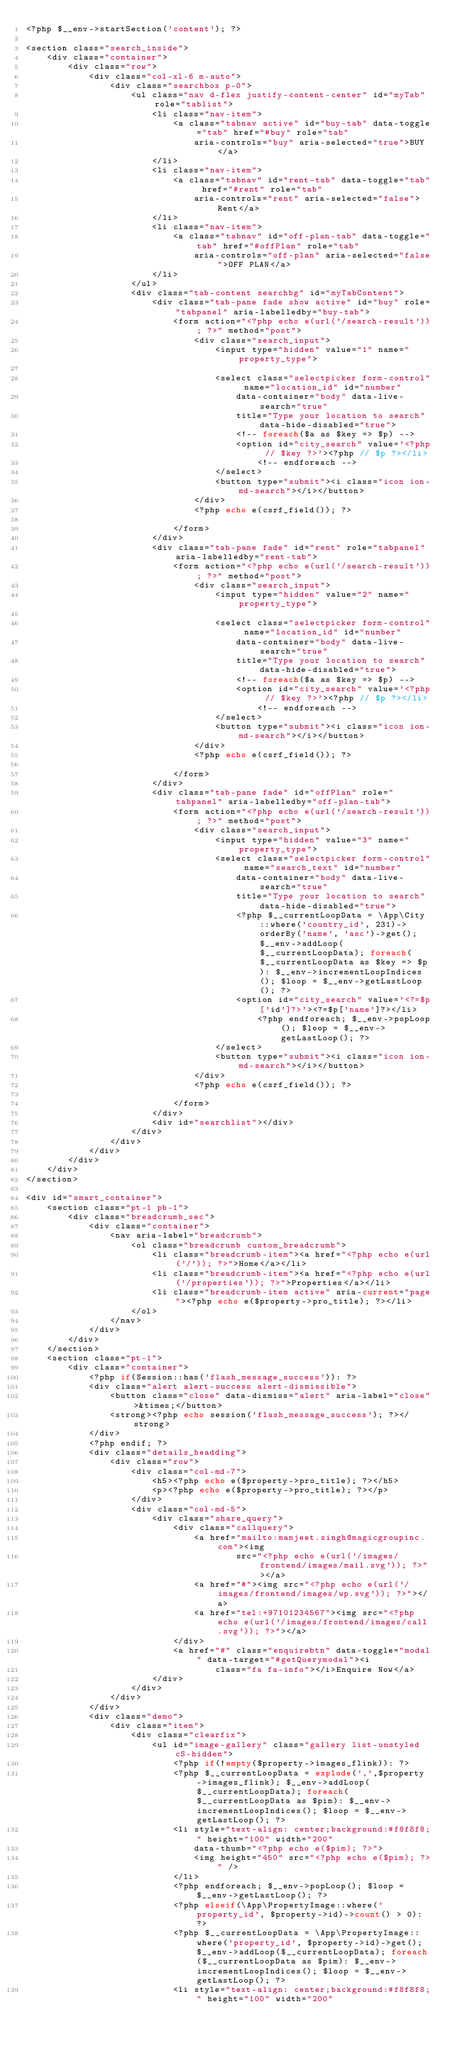<code> <loc_0><loc_0><loc_500><loc_500><_PHP_><?php $__env->startSection('content'); ?>

<section class="search_inside">
    <div class="container">
        <div class="row">
            <div class="col-xl-6 m-auto">
                <div class="searchbox p-0">
                    <ul class="nav d-flex justify-content-center" id="myTab" role="tablist">
                        <li class="nav-item">
                            <a class="tabnav active" id="buy-tab" data-toggle="tab" href="#buy" role="tab"
                                aria-controls="buy" aria-selected="true">BUY</a>
                        </li>
                        <li class="nav-item">
                            <a class="tabnav" id="rent-tab" data-toggle="tab" href="#rent" role="tab"
                                aria-controls="rent" aria-selected="false">Rent</a>
                        </li>
                        <li class="nav-item">
                            <a class="tabnav" id="off-plan-tab" data-toggle="tab" href="#offPlan" role="tab"
                                aria-controls="off-plan" aria-selected="false">OFF PLAN</a>
                        </li>
                    </ul>
                    <div class="tab-content searchbg" id="myTabContent">
                        <div class="tab-pane fade show active" id="buy" role="tabpanel" aria-labelledby="buy-tab">
                            <form action="<?php echo e(url('/search-result')); ?>" method="post">
                                <div class="search_input">
                                    <input type="hidden" value="1" name="property_type">

                                    <select class="selectpicker form-control" name="location_id" id="number"
                                        data-container="body" data-live-search="true"
                                        title="Type your location to search" data-hide-disabled="true">
                                        <!-- foreach($a as $key => $p) -->
                                        <option id="city_search" value='<?php // $key ?>'><?php // $p ?></li>
                                            <!-- endforeach -->
                                    </select>
                                    <button type="submit"><i class="icon ion-md-search"></i></button>
                                </div>
                                <?php echo e(csrf_field()); ?>

                            </form>
                        </div>
                        <div class="tab-pane fade" id="rent" role="tabpanel" aria-labelledby="rent-tab">
                            <form action="<?php echo e(url('/search-result')); ?>" method="post">
                                <div class="search_input">
                                    <input type="hidden" value="2" name="property_type">

                                    <select class="selectpicker form-control" name="location_id" id="number"
                                        data-container="body" data-live-search="true"
                                        title="Type your location to search" data-hide-disabled="true">
                                        <!-- foreach($a as $key => $p) -->
                                        <option id="city_search" value='<?php // $key ?>'><?php // $p ?></li>
                                            <!-- endforeach -->
                                    </select>
                                    <button type="submit"><i class="icon ion-md-search"></i></button>
                                </div>
                                <?php echo e(csrf_field()); ?>

                            </form>
                        </div>
                        <div class="tab-pane fade" id="offPlan" role="tabpanel" aria-labelledby="off-plan-tab">
                            <form action="<?php echo e(url('/search-result')); ?>" method="post">
                                <div class="search_input">
                                    <input type="hidden" value="3" name="property_type">
                                    <select class="selectpicker form-control" name="search_text" id="number"
                                        data-container="body" data-live-search="true"
                                        title="Type your location to search" data-hide-disabled="true">
                                        <?php $__currentLoopData = \App\City::where('country_id', 231)->orderBy('name', 'asc')->get(); $__env->addLoop($__currentLoopData); foreach($__currentLoopData as $key => $p): $__env->incrementLoopIndices(); $loop = $__env->getLastLoop(); ?>
                                        <option id="city_search" value='<?=$p['id']?>'><?=$p['name']?></li>
                                            <?php endforeach; $__env->popLoop(); $loop = $__env->getLastLoop(); ?>
                                    </select>
                                    <button type="submit"><i class="icon ion-md-search"></i></button>
                                </div>
                                <?php echo e(csrf_field()); ?>

                            </form>
                        </div>
                        <div id="searchlist"></div>
                    </div>
                </div>
            </div>
        </div>
    </div>
</section>

<div id="smart_container">
    <section class="pt-1 pb-1">
        <div class="breadcrumb_sec">
            <div class="container">
                <nav aria-label="breadcrumb">
                    <ol class="breadcrumb custom_breadcrumb">
                        <li class="breadcrumb-item"><a href="<?php echo e(url('/')); ?>">Home</a></li>
                        <li class="breadcrumb-item"><a href="<?php echo e(url('/properties')); ?>">Properties</a></li>
                        <li class="breadcrumb-item active" aria-current="page"><?php echo e($property->pro_title); ?></li>
                    </ol>
                </nav>
            </div>
        </div>
    </section>
    <section class="pt-1">
        <div class="container">
            <?php if(Session::has('flash_message_success')): ?>
            <div class="alert alert-success alert-dismissible">
                <button class="close" data-dismiss="alert" aria-label="close">&times;</button>
                <strong><?php echo session('flash_message_success'); ?></strong>
            </div>
            <?php endif; ?>
            <div class="details_headding">
                <div class="row">
                    <div class="col-md-7">
                        <h5><?php echo e($property->pro_title); ?></h5>
                        <p><?php echo e($property->pro_title); ?></p>
                    </div>
                    <div class="col-md-5">
                        <div class="share_query">
                            <div class="callquery">
                                <a href="mailto:manjeet.singh@magicgroupinc.com"><img
                                        src="<?php echo e(url('/images/frontend/images/mail.svg')); ?>"></a>
                                <a href="#"><img src="<?php echo e(url('/images/frontend/images/wp.svg')); ?>"></a>
                                <a href="tel:+97101234567"><img src="<?php echo e(url('/images/frontend/images/call.svg')); ?>"></a>
                            </div>
                            <a href="#" class="enquirebtn" data-toggle="modal" data-target="#getQuerymodal"><i
                                    class="fa fa-info"></i>Enquire Now</a>
                        </div>
                    </div>
                </div>
            </div>
            <div class="demo">
                <div class="item">
                    <div class="clearfix">
                        <ul id="image-gallery" class="gallery list-unstyled cS-hidden">
                            <?php if(!empty($property->images_flink)): ?>
                            <?php $__currentLoopData = explode(',',$property->images_flink); $__env->addLoop($__currentLoopData); foreach($__currentLoopData as $pim): $__env->incrementLoopIndices(); $loop = $__env->getLastLoop(); ?>
                            <li style="text-align: center;background:#f8f8f8;" height="100" width="200"
                                data-thumb="<?php echo e($pim); ?>">
                                <img height="450" src="<?php echo e($pim); ?>" />
                            </li>
                            <?php endforeach; $__env->popLoop(); $loop = $__env->getLastLoop(); ?>
                            <?php elseif(\App\PropertyImage::where('property_id', $property->id)->count() > 0): ?>
                            <?php $__currentLoopData = \App\PropertyImage::where('property_id', $property->id)->get(); $__env->addLoop($__currentLoopData); foreach($__currentLoopData as $pim): $__env->incrementLoopIndices(); $loop = $__env->getLastLoop(); ?>
                            <li style="text-align: center;background:#f8f8f8;" height="100" width="200"</code> 